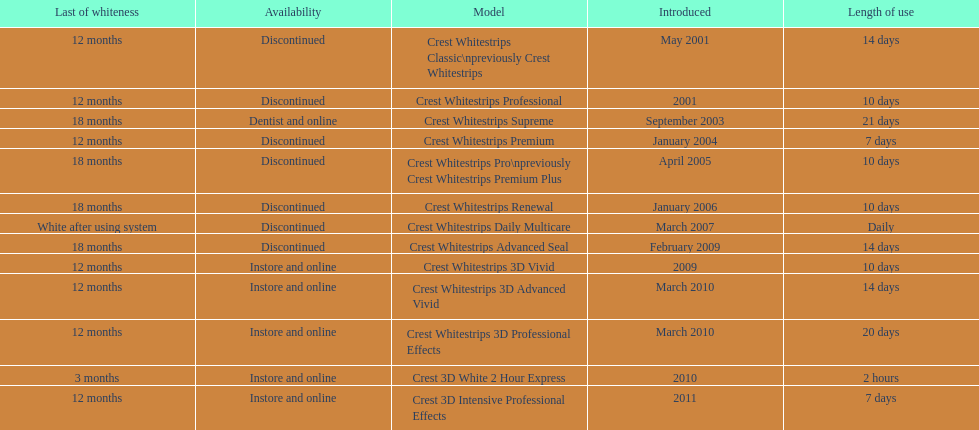How many models require less than a week of use? 2. Could you help me parse every detail presented in this table? {'header': ['Last of whiteness', 'Availability', 'Model', 'Introduced', 'Length of use'], 'rows': [['12 months', 'Discontinued', 'Crest Whitestrips Classic\\npreviously Crest Whitestrips', 'May 2001', '14 days'], ['12 months', 'Discontinued', 'Crest Whitestrips Professional', '2001', '10 days'], ['18 months', 'Dentist and online', 'Crest Whitestrips Supreme', 'September 2003', '21 days'], ['12 months', 'Discontinued', 'Crest Whitestrips Premium', 'January 2004', '7 days'], ['18 months', 'Discontinued', 'Crest Whitestrips Pro\\npreviously Crest Whitestrips Premium Plus', 'April 2005', '10 days'], ['18 months', 'Discontinued', 'Crest Whitestrips Renewal', 'January 2006', '10 days'], ['White after using system', 'Discontinued', 'Crest Whitestrips Daily Multicare', 'March 2007', 'Daily'], ['18 months', 'Discontinued', 'Crest Whitestrips Advanced Seal', 'February 2009', '14 days'], ['12 months', 'Instore and online', 'Crest Whitestrips 3D Vivid', '2009', '10 days'], ['12 months', 'Instore and online', 'Crest Whitestrips 3D Advanced Vivid', 'March 2010', '14 days'], ['12 months', 'Instore and online', 'Crest Whitestrips 3D Professional Effects', 'March 2010', '20 days'], ['3 months', 'Instore and online', 'Crest 3D White 2 Hour Express', '2010', '2 hours'], ['12 months', 'Instore and online', 'Crest 3D Intensive Professional Effects', '2011', '7 days']]} 